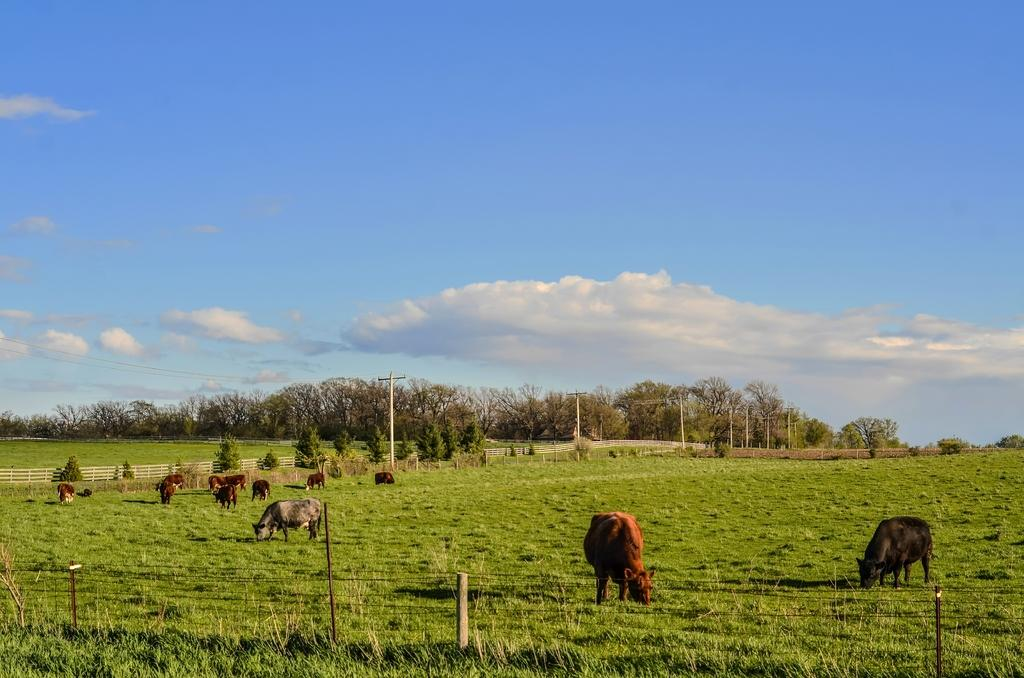What type of living organisms can be seen in the image? There are animals in the image. What are the animals doing in the image? The animals are grazing grass. What can be seen in the background of the image? There are trees in the background of the image. What is visible at the top of the image? The sky is visible at the top of the image. Where is the mine located in the image? There is no mine present in the image. Is there a party happening in the image? There is no indication of a party in the image; it features animals grazing grass. 